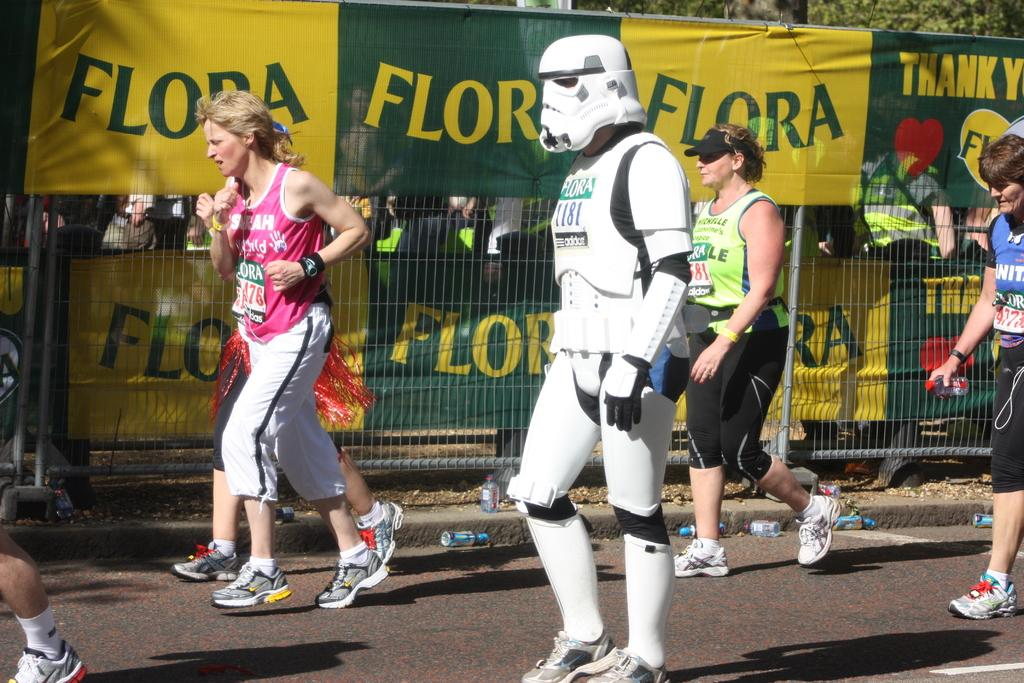Provide a one-sentence caption for the provided image. A person in a storm trooper costume and other various runners run in front of several banners that say Flora. 